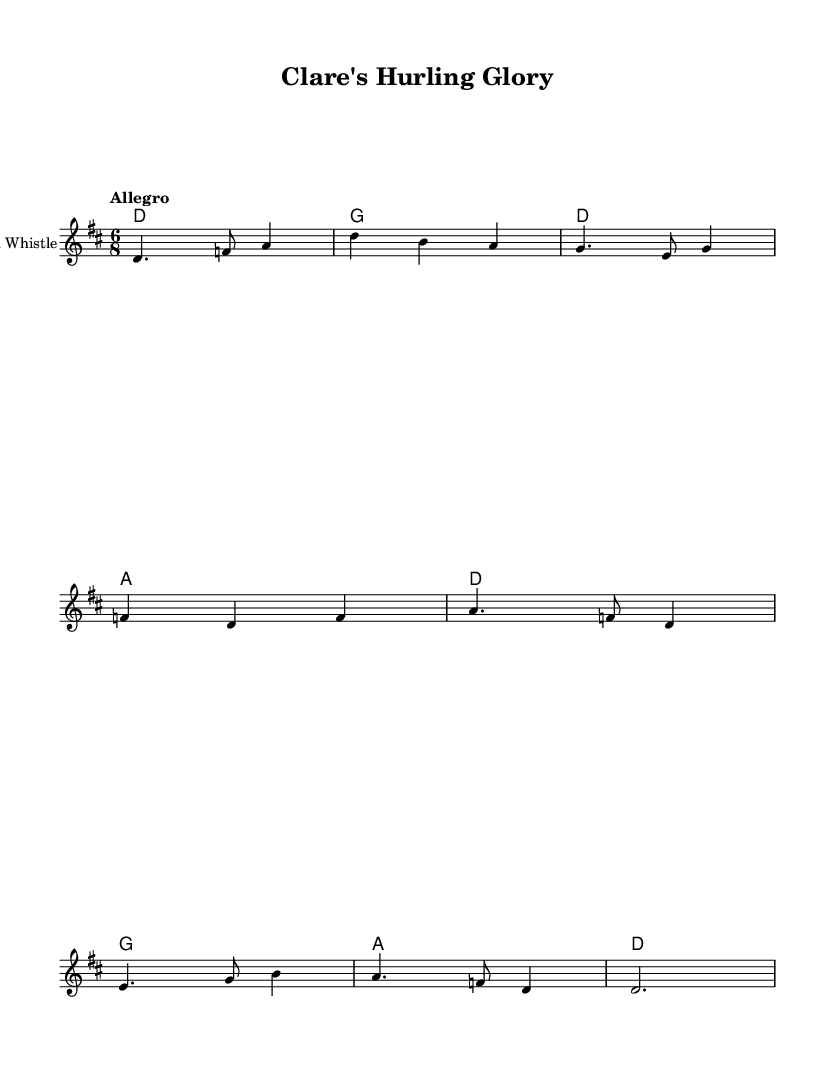What is the key signature of this music? The key signature is indicated at the beginning of the staff after the \key command. It shows two sharps, which corresponds to D major.
Answer: D major What is the time signature of this music? The time signature is also indicated at the beginning of the score. It shows a 6 over 8, meaning there are six eighth notes in each measure.
Answer: 6/8 What is the tempo marking for this piece? The tempo marking is found next to the \tempo command in the score, indicating the speed at which the piece should be played. It reads "Allegro," meaning fast and lively.
Answer: Allegro How many measures are in the melody? By counting the distinct groups of notes separated by vertical lines (bar lines), we can find the number of measures. There are eight measures in the melody part.
Answer: Eight What do the lyrics in the chorus celebrate? The lyrics in the chorus refer directly to the pride associated with hurling in Clare, naming specific locations that evoke local sports culture, highlighting their heritage.
Answer: Hurling pride What instruments are indicated for this score? The score specifies the instruments used in the performance through the \new Staff command. It mentions "Tin Whistle," which is a traditional Irish instrument commonly used in folk music.
Answer: Tin Whistle What is the form of the song based on the structure provided? The structure indicates that there is a verse followed by a chorus, which is typical in folk music. Therefore, the form is verse-chorus.
Answer: Verse-Chorus 